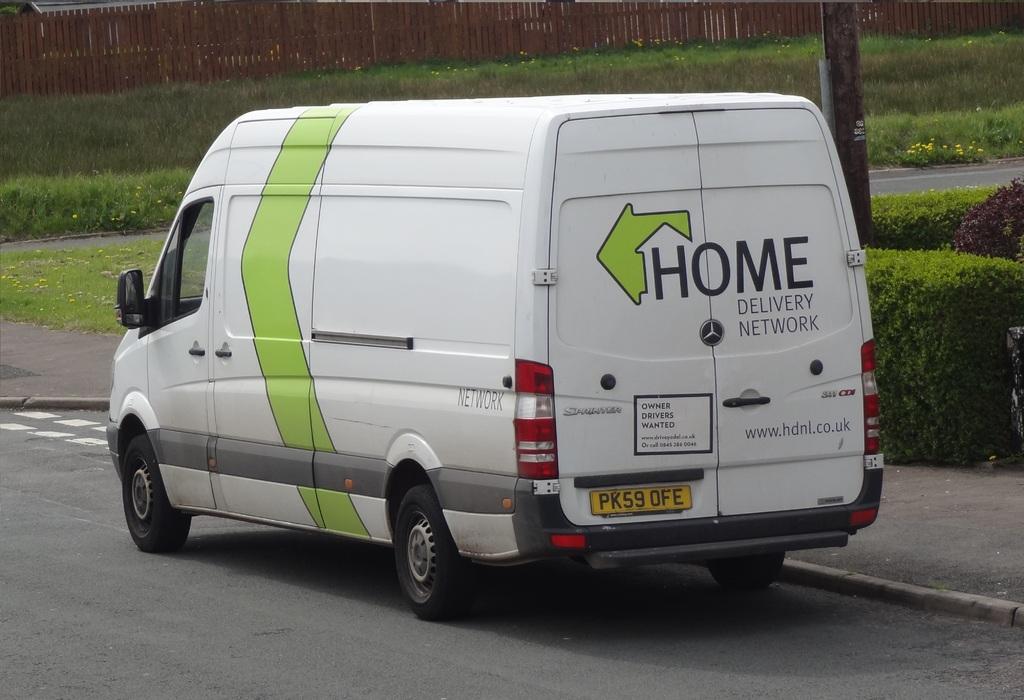What does the company specialize in?
Your response must be concise. Home delivery. What is the website for this company?
Keep it short and to the point. Www.hdnl.co.uk. 